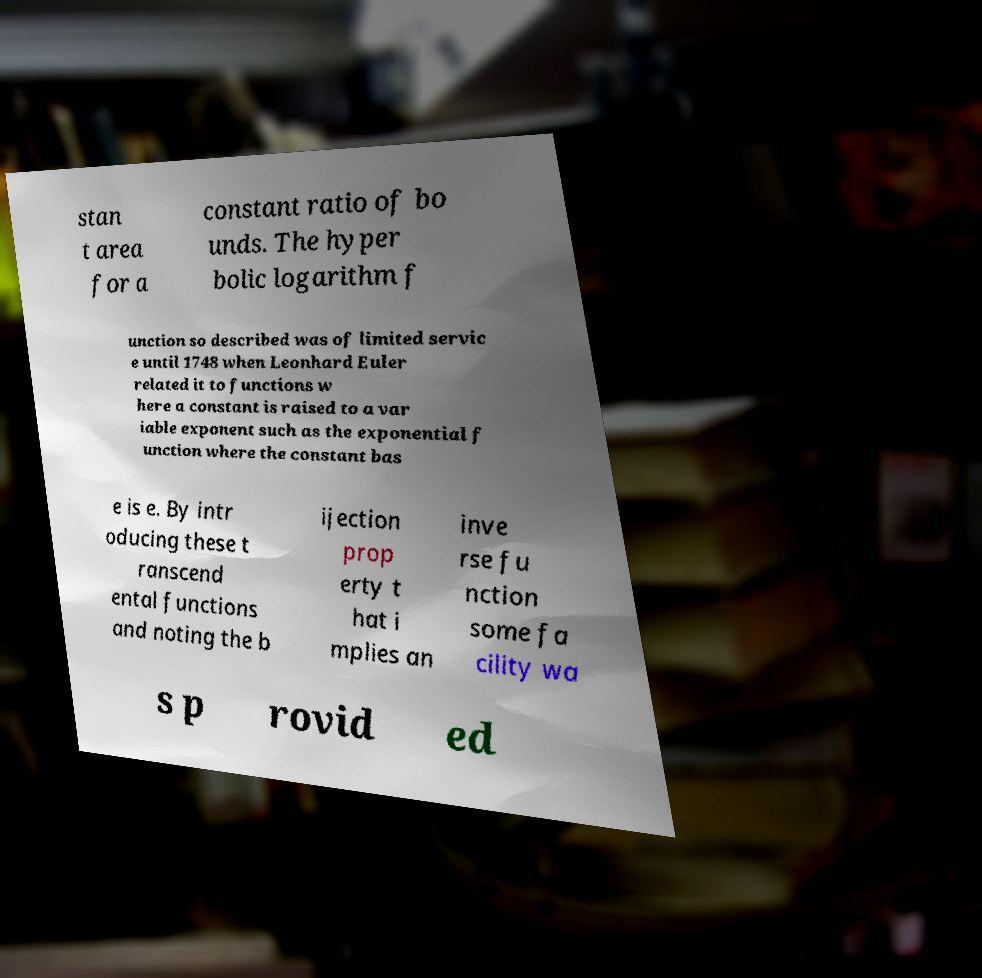Can you read and provide the text displayed in the image?This photo seems to have some interesting text. Can you extract and type it out for me? stan t area for a constant ratio of bo unds. The hyper bolic logarithm f unction so described was of limited servic e until 1748 when Leonhard Euler related it to functions w here a constant is raised to a var iable exponent such as the exponential f unction where the constant bas e is e. By intr oducing these t ranscend ental functions and noting the b ijection prop erty t hat i mplies an inve rse fu nction some fa cility wa s p rovid ed 